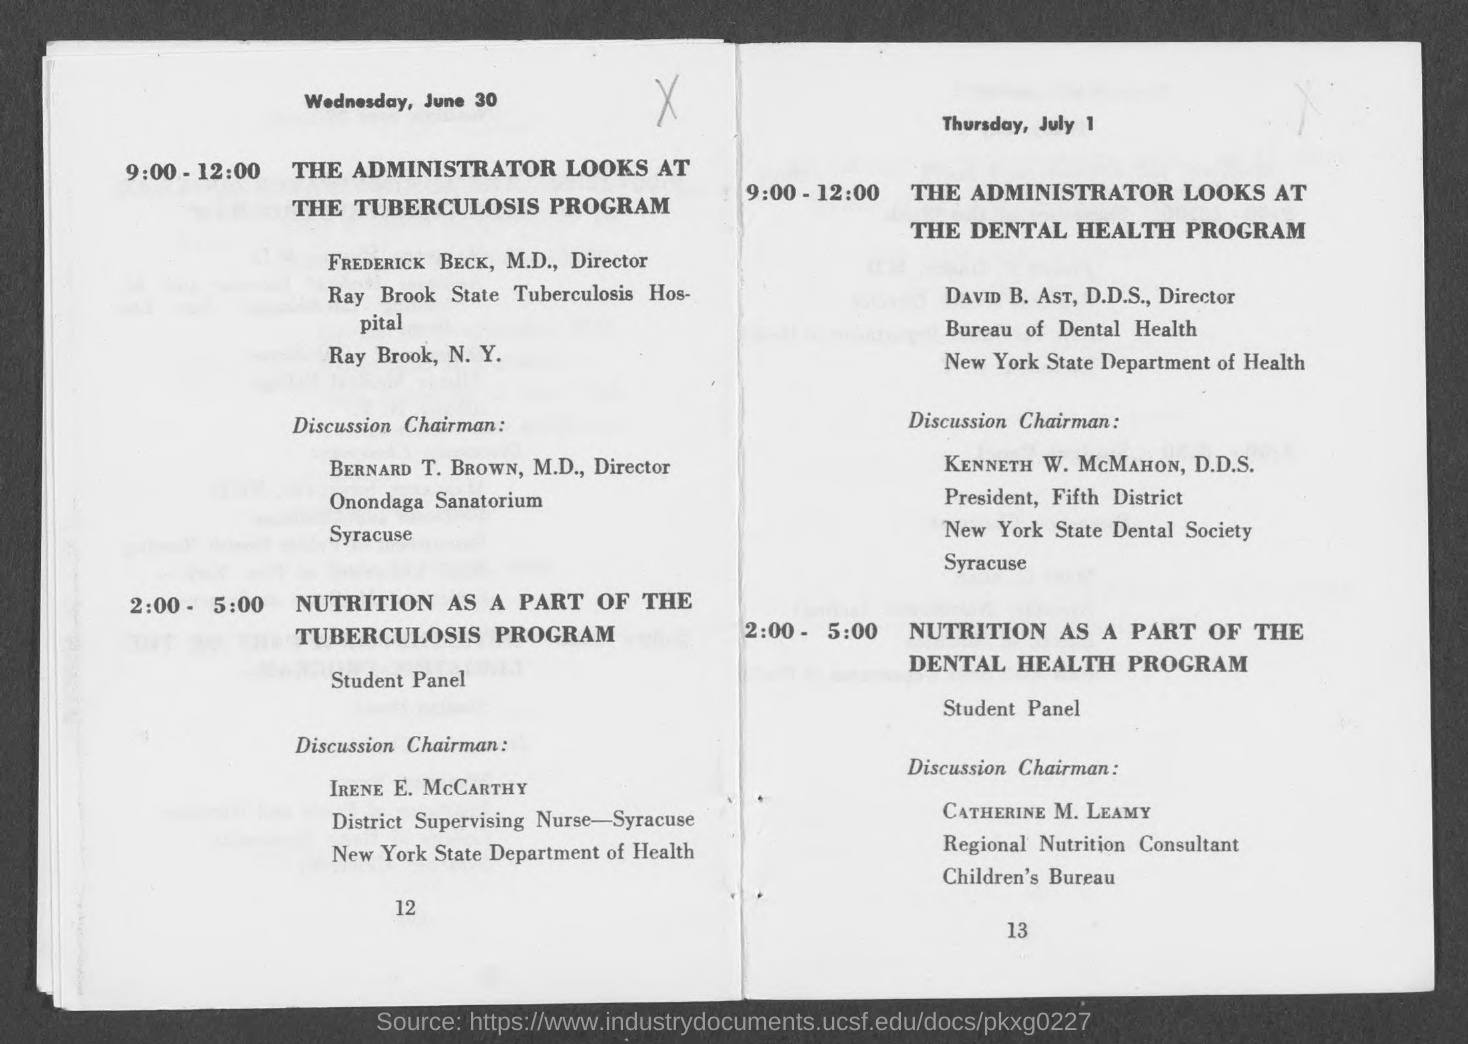Indicate a few pertinent items in this graphic. The date mentioned on page 12 is Wednesday, June 30. The individual responsible for leading the discussion on nutrition as part of the tuberculosis program is Irene E. McCarthy. Bernard T. Brown holds the designation of director. 